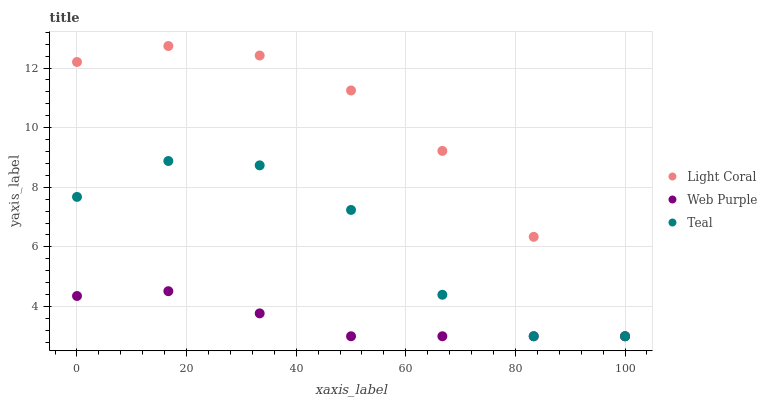Does Web Purple have the minimum area under the curve?
Answer yes or no. Yes. Does Light Coral have the maximum area under the curve?
Answer yes or no. Yes. Does Teal have the minimum area under the curve?
Answer yes or no. No. Does Teal have the maximum area under the curve?
Answer yes or no. No. Is Web Purple the smoothest?
Answer yes or no. Yes. Is Teal the roughest?
Answer yes or no. Yes. Is Teal the smoothest?
Answer yes or no. No. Is Web Purple the roughest?
Answer yes or no. No. Does Light Coral have the lowest value?
Answer yes or no. Yes. Does Light Coral have the highest value?
Answer yes or no. Yes. Does Teal have the highest value?
Answer yes or no. No. Does Light Coral intersect Web Purple?
Answer yes or no. Yes. Is Light Coral less than Web Purple?
Answer yes or no. No. Is Light Coral greater than Web Purple?
Answer yes or no. No. 